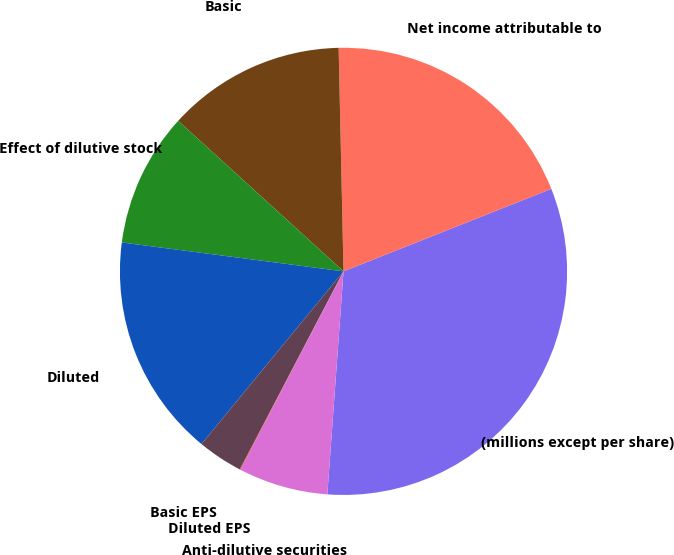Convert chart. <chart><loc_0><loc_0><loc_500><loc_500><pie_chart><fcel>(millions except per share)<fcel>Net income attributable to<fcel>Basic<fcel>Effect of dilutive stock<fcel>Diluted<fcel>Basic EPS<fcel>Diluted EPS<fcel>Anti-dilutive securities<nl><fcel>32.17%<fcel>19.33%<fcel>12.9%<fcel>9.69%<fcel>16.11%<fcel>3.27%<fcel>0.05%<fcel>6.48%<nl></chart> 